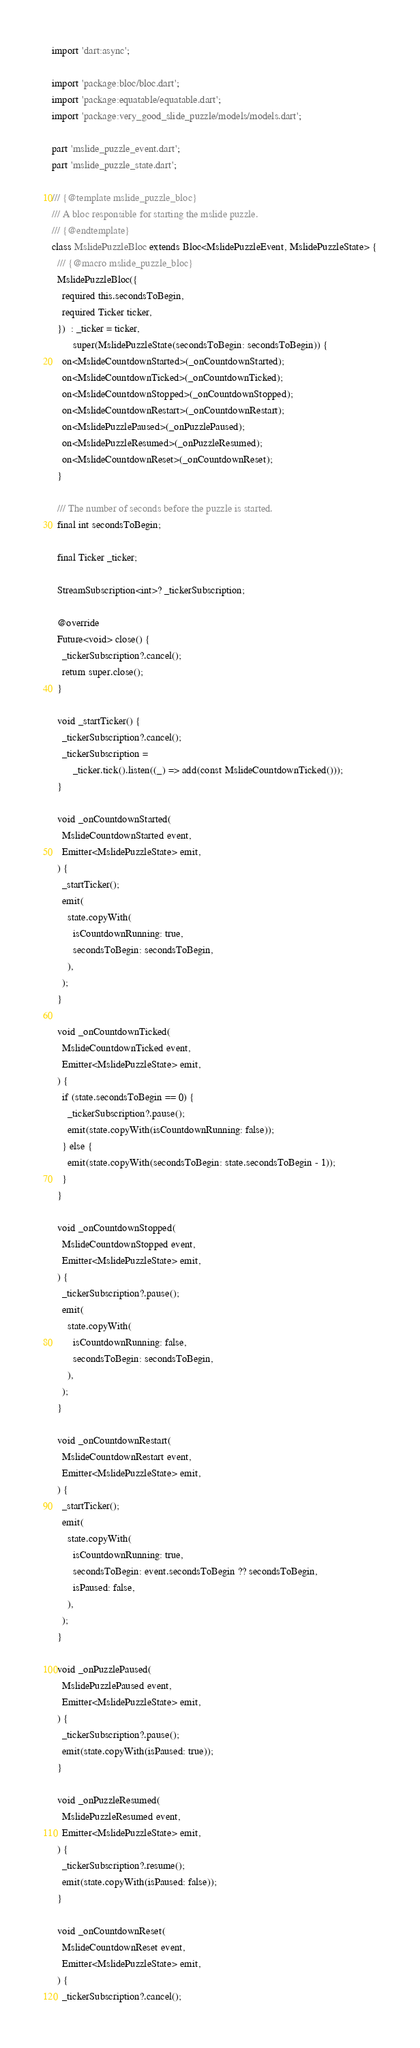Convert code to text. <code><loc_0><loc_0><loc_500><loc_500><_Dart_>import 'dart:async';

import 'package:bloc/bloc.dart';
import 'package:equatable/equatable.dart';
import 'package:very_good_slide_puzzle/models/models.dart';

part 'mslide_puzzle_event.dart';
part 'mslide_puzzle_state.dart';

/// {@template mslide_puzzle_bloc}
/// A bloc responsible for starting the mslide puzzle.
/// {@endtemplate}
class MslidePuzzleBloc extends Bloc<MslidePuzzleEvent, MslidePuzzleState> {
  /// {@macro mslide_puzzle_bloc}
  MslidePuzzleBloc({
    required this.secondsToBegin,
    required Ticker ticker,
  })  : _ticker = ticker,
        super(MslidePuzzleState(secondsToBegin: secondsToBegin)) {
    on<MslideCountdownStarted>(_onCountdownStarted);
    on<MslideCountdownTicked>(_onCountdownTicked);
    on<MslideCountdownStopped>(_onCountdownStopped);
    on<MslideCountdownRestart>(_onCountdownRestart);
    on<MslidePuzzlePaused>(_onPuzzlePaused);
    on<MslidePuzzleResumed>(_onPuzzleResumed);
    on<MslideCountdownReset>(_onCountdownReset);
  }

  /// The number of seconds before the puzzle is started.
  final int secondsToBegin;

  final Ticker _ticker;

  StreamSubscription<int>? _tickerSubscription;

  @override
  Future<void> close() {
    _tickerSubscription?.cancel();
    return super.close();
  }

  void _startTicker() {
    _tickerSubscription?.cancel();
    _tickerSubscription =
        _ticker.tick().listen((_) => add(const MslideCountdownTicked()));
  }

  void _onCountdownStarted(
    MslideCountdownStarted event,
    Emitter<MslidePuzzleState> emit,
  ) {
    _startTicker();
    emit(
      state.copyWith(
        isCountdownRunning: true,
        secondsToBegin: secondsToBegin,
      ),
    );
  }

  void _onCountdownTicked(
    MslideCountdownTicked event,
    Emitter<MslidePuzzleState> emit,
  ) {
    if (state.secondsToBegin == 0) {
      _tickerSubscription?.pause();
      emit(state.copyWith(isCountdownRunning: false));
    } else {
      emit(state.copyWith(secondsToBegin: state.secondsToBegin - 1));
    }
  }

  void _onCountdownStopped(
    MslideCountdownStopped event,
    Emitter<MslidePuzzleState> emit,
  ) {
    _tickerSubscription?.pause();
    emit(
      state.copyWith(
        isCountdownRunning: false,
        secondsToBegin: secondsToBegin,
      ),
    );
  }

  void _onCountdownRestart(
    MslideCountdownRestart event,
    Emitter<MslidePuzzleState> emit,
  ) {
    _startTicker();
    emit(
      state.copyWith(
        isCountdownRunning: true,
        secondsToBegin: event.secondsToBegin ?? secondsToBegin,
        isPaused: false,
      ),
    );
  }

  void _onPuzzlePaused(
    MslidePuzzlePaused event,
    Emitter<MslidePuzzleState> emit,
  ) {
    _tickerSubscription?.pause();
    emit(state.copyWith(isPaused: true));
  }

  void _onPuzzleResumed(
    MslidePuzzleResumed event,
    Emitter<MslidePuzzleState> emit,
  ) {
    _tickerSubscription?.resume();
    emit(state.copyWith(isPaused: false));
  }

  void _onCountdownReset(
    MslideCountdownReset event,
    Emitter<MslidePuzzleState> emit,
  ) {
    _tickerSubscription?.cancel();</code> 